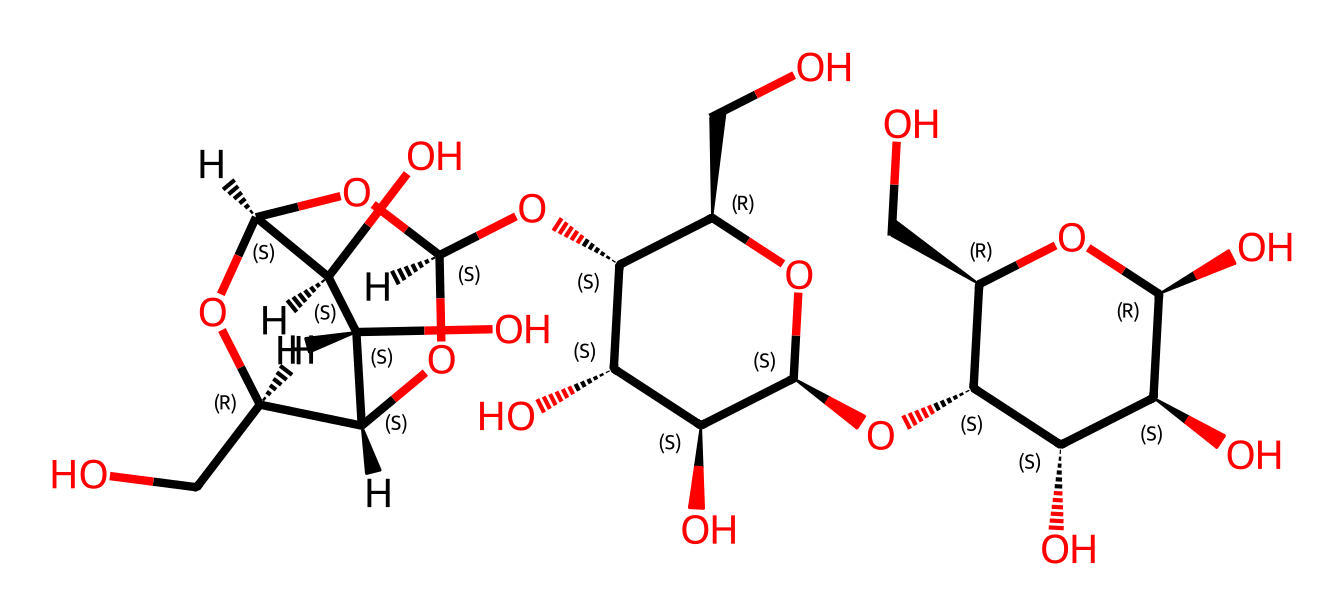What is the main type of chemical represented by this structure? This structure represents cellulose, which is a polysaccharide (a type of carbohydrate) commonly found in plant cell walls. The multiple hydroxyl (–OH) groups indicate its carbohydrate nature.
Answer: cellulose How many rings are present in this molecular structure? The structure shows three distinct ring formations, specifically in the structure of cellulose, which contains multiple glucose units linked together in a cyclic manner.
Answer: three What functional groups are present in this chemical? The dominant functional group in this structure is the hydroxyl group (–OH), indicative of its properties as a carbohydrate, which plays a critical role in hydrogen bonding.
Answer: hydroxyl Count the total number of carbon atoms in the structure. By analyzing the SMILES representation, it can be determined that there are a total of 18 carbon atoms that make up the backbone of the cellulose molecule.
Answer: 18 Given the structure, what is the primary role of cellulose in soundproofing panels? Cellulose serves as a fibrous material that enhances sound absorption due to its porous structure, which helps in dampening sound waves effectively.
Answer: sound absorption Which part of the structure makes it hydrophilic? The presence of numerous hydroxyl (–OH) groups in the cellulose structure contributes to its hydrophilicity, allowing it to interact favorably with water molecules.
Answer: hydroxyl groups How does the structure of cellulose contribute to its strength in wooden panels? The extensive hydrogen bonding between cellulose chains provides structural integrity and tensile strength, making wooden acoustic panels durable and effective for soundproofing applications.
Answer: hydrogen bonding 